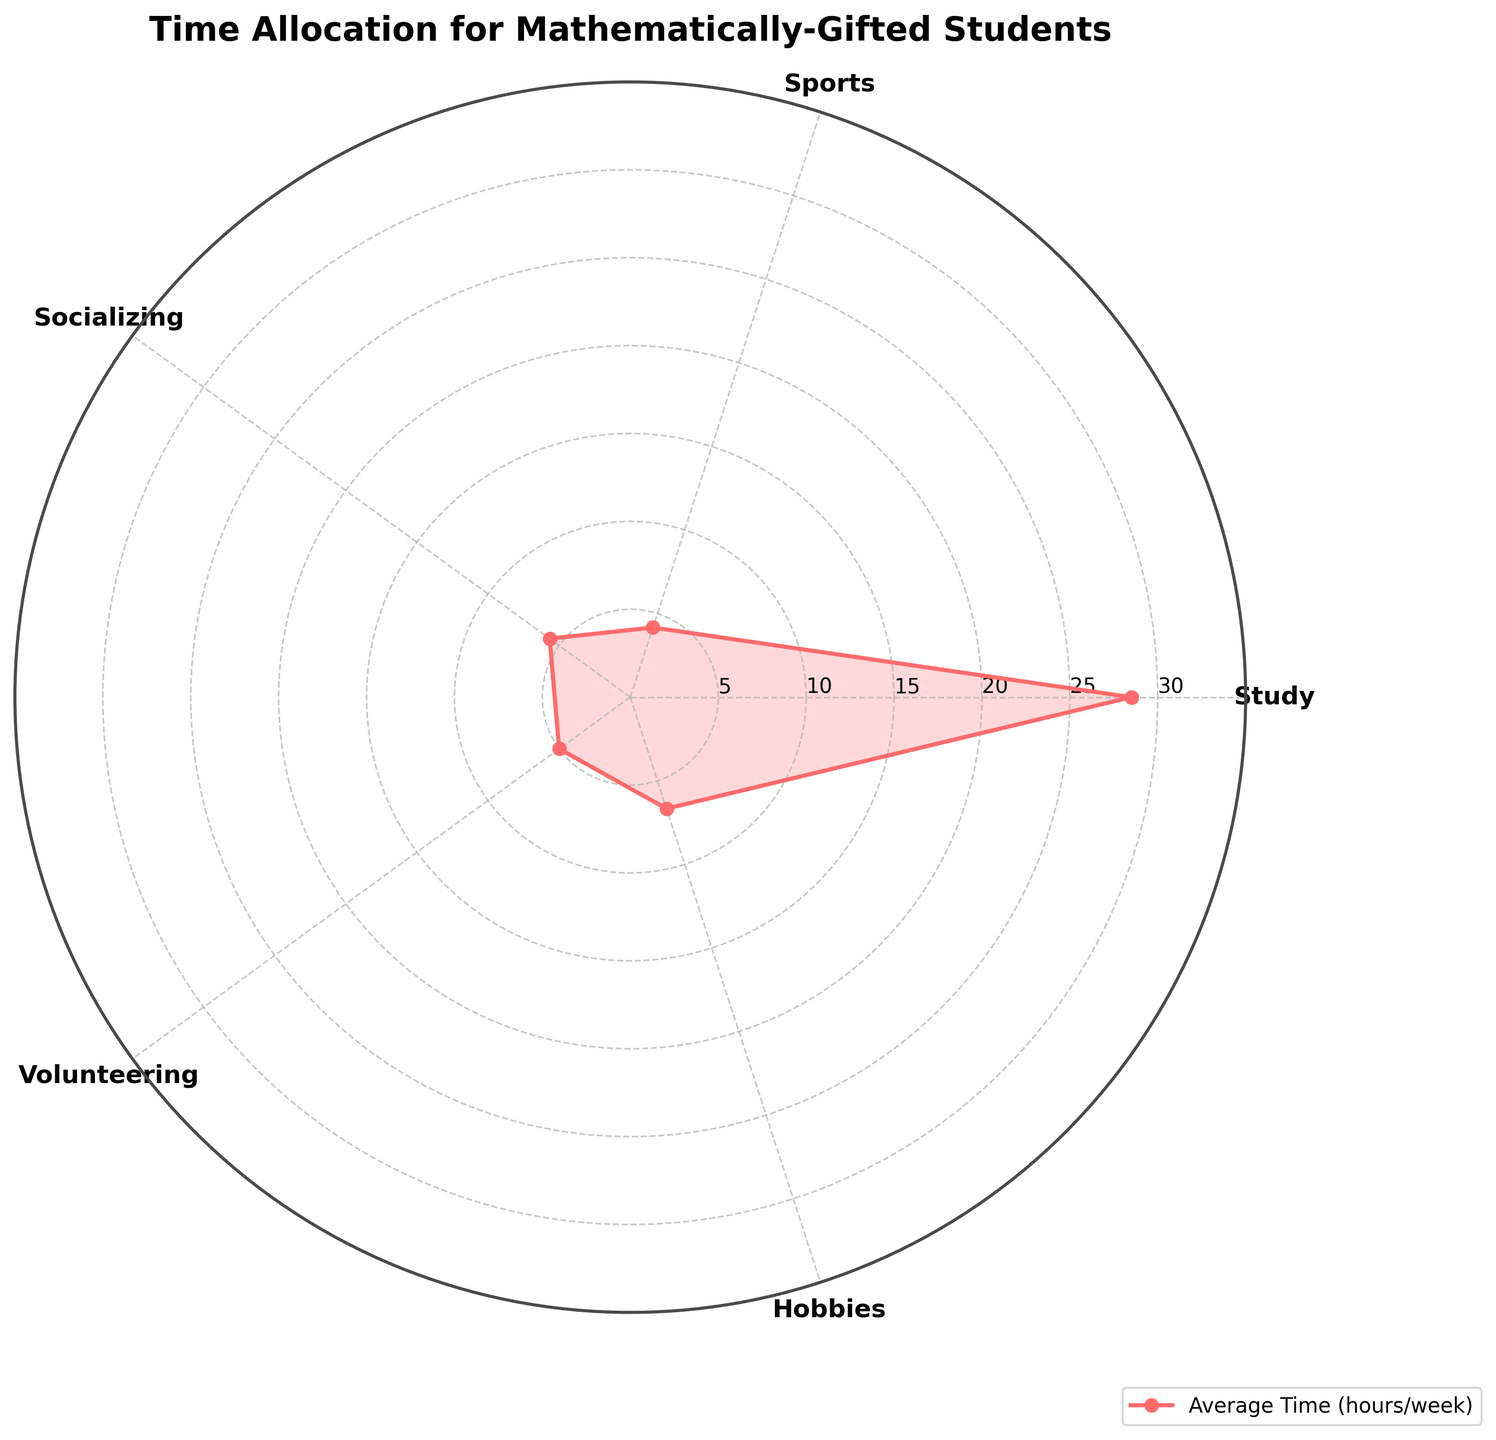What's the title of the radar chart? The title of the radar chart is positioned at the top in bold text.
Answer: Time Allocation for Mathematically-Gifted Students What are the categories shown on the radar chart? The categories can be seen around the radar chart, labeled at each of the vertices.
Answer: Study, Sports, Socializing, Volunteering, Hobbies What is the average time spent on Sports? The data point for Sports can be found directly by looking up the value on the corresponding axis of the radar chart.
Answer: 4.2 hours/week On which activity do mathematically-gifted students spend the most time? By comparing the distances from the center for each category, the longest distance corresponds to the highest value.
Answer: Study Which category has the smallest average time allocation? By comparing the points closest to the center along the axes from the origin, the shortest distance corresponds to the smallest value.
Answer: Sports Are the average time spent on Socializing and Volunteering equal? Check the values for Socializing and Volunteering and compare them. They should be plotted at the same distance from the center.
Answer: Yes What is the summed total average time spent on Study, Hobbies, and Socializing? Add the average values of Study (28.5), Hobbies (6.7), and Socializing (5.7).
Answer: 40.9 hours/week Is the average time spent on Hobbies more than that on Volunteering? Check the lengths of the vectors leading to Hobbies and Volunteering.
Answer: Yes Which activity shows the most variation in hours spent among students? Look for the category with the furthest spread in individual values or observe more complex analysis if presented.
Answer: Study 